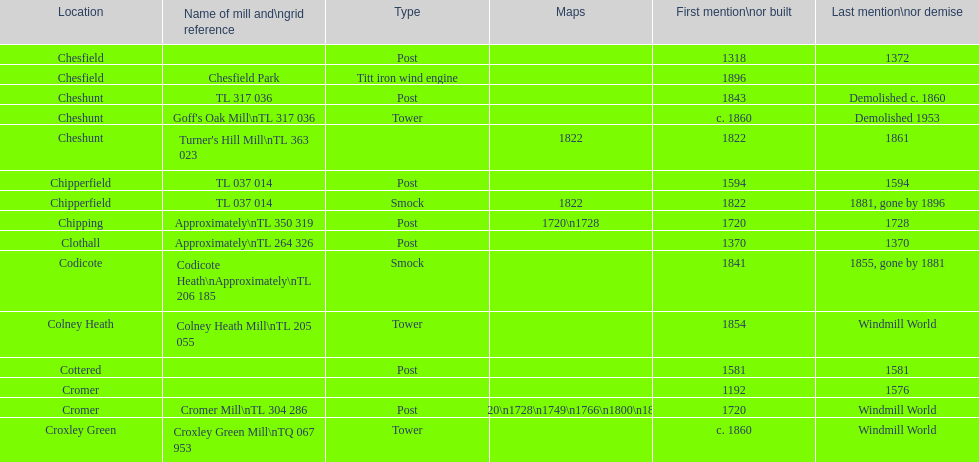How many mills are there with the name cheshunt? 3. 